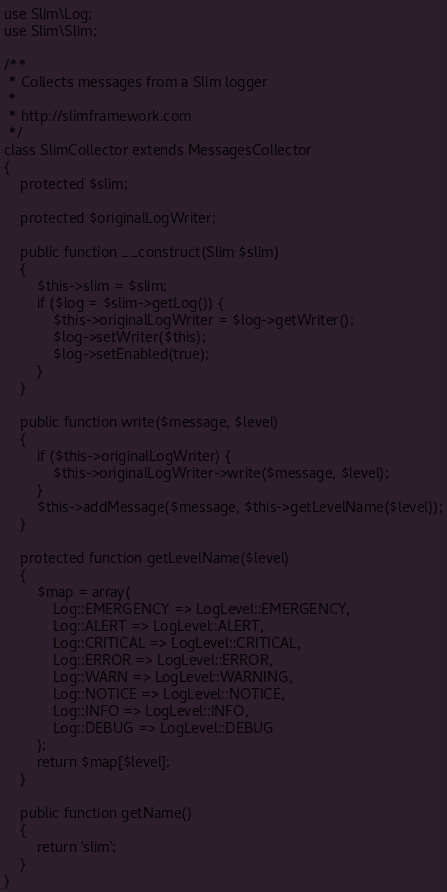Convert code to text. <code><loc_0><loc_0><loc_500><loc_500><_PHP_>use Slim\Log;
use Slim\Slim;

/**
 * Collects messages from a Slim logger
 *
 * http://slimframework.com
 */
class SlimCollector extends MessagesCollector
{
    protected $slim;

    protected $originalLogWriter;

    public function __construct(Slim $slim)
    {
        $this->slim = $slim;
        if ($log = $slim->getLog()) {
            $this->originalLogWriter = $log->getWriter();
            $log->setWriter($this);
            $log->setEnabled(true);
        }
    }

    public function write($message, $level)
    {
        if ($this->originalLogWriter) {
            $this->originalLogWriter->write($message, $level);
        }
        $this->addMessage($message, $this->getLevelName($level));
    }

    protected function getLevelName($level)
    {
        $map = array(
            Log::EMERGENCY => LogLevel::EMERGENCY,
            Log::ALERT => LogLevel::ALERT,
            Log::CRITICAL => LogLevel::CRITICAL,
            Log::ERROR => LogLevel::ERROR,
            Log::WARN => LogLevel::WARNING,
            Log::NOTICE => LogLevel::NOTICE,
            Log::INFO => LogLevel::INFO,
            Log::DEBUG => LogLevel::DEBUG
        );
        return $map[$level];
    }

    public function getName()
    {
        return 'slim';
    }
}
</code> 